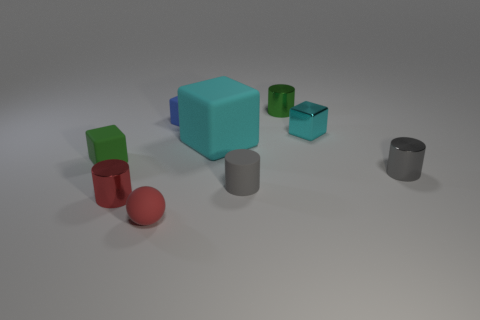Subtract all big cyan blocks. How many blocks are left? 3 Add 1 blue matte objects. How many objects exist? 10 Subtract all gray cylinders. How many cylinders are left? 2 Subtract all balls. How many objects are left? 8 Add 1 green metallic things. How many green metallic things are left? 2 Add 1 big purple shiny things. How many big purple shiny things exist? 1 Subtract 0 cyan spheres. How many objects are left? 9 Subtract 1 blocks. How many blocks are left? 3 Subtract all red cylinders. Subtract all purple blocks. How many cylinders are left? 3 Subtract all cyan spheres. How many purple cubes are left? 0 